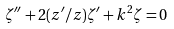Convert formula to latex. <formula><loc_0><loc_0><loc_500><loc_500>\zeta ^ { \prime \prime } + 2 ( z ^ { \prime } / z ) \zeta ^ { \prime } + k ^ { 2 } \zeta = 0</formula> 